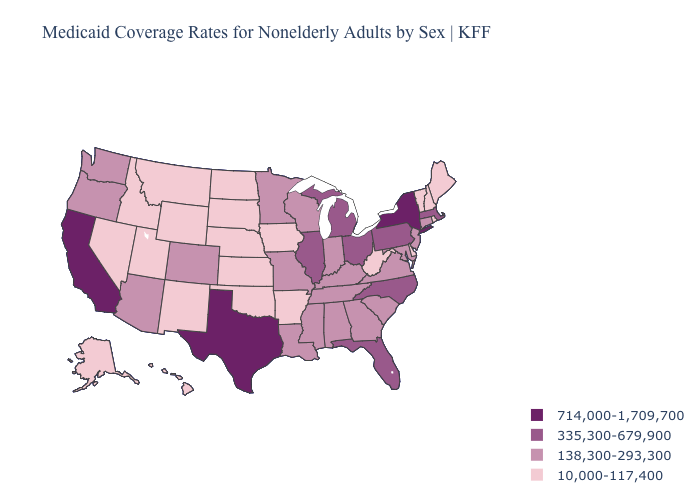Does Washington have a lower value than Ohio?
Keep it brief. Yes. Name the states that have a value in the range 10,000-117,400?
Concise answer only. Alaska, Arkansas, Delaware, Hawaii, Idaho, Iowa, Kansas, Maine, Montana, Nebraska, Nevada, New Hampshire, New Mexico, North Dakota, Oklahoma, Rhode Island, South Dakota, Utah, Vermont, West Virginia, Wyoming. Does Colorado have the highest value in the USA?
Concise answer only. No. Name the states that have a value in the range 10,000-117,400?
Be succinct. Alaska, Arkansas, Delaware, Hawaii, Idaho, Iowa, Kansas, Maine, Montana, Nebraska, Nevada, New Hampshire, New Mexico, North Dakota, Oklahoma, Rhode Island, South Dakota, Utah, Vermont, West Virginia, Wyoming. What is the lowest value in states that border Kansas?
Give a very brief answer. 10,000-117,400. Name the states that have a value in the range 714,000-1,709,700?
Quick response, please. California, New York, Texas. How many symbols are there in the legend?
Keep it brief. 4. Name the states that have a value in the range 10,000-117,400?
Be succinct. Alaska, Arkansas, Delaware, Hawaii, Idaho, Iowa, Kansas, Maine, Montana, Nebraska, Nevada, New Hampshire, New Mexico, North Dakota, Oklahoma, Rhode Island, South Dakota, Utah, Vermont, West Virginia, Wyoming. Name the states that have a value in the range 138,300-293,300?
Keep it brief. Alabama, Arizona, Colorado, Connecticut, Georgia, Indiana, Kentucky, Louisiana, Maryland, Minnesota, Mississippi, Missouri, New Jersey, Oregon, South Carolina, Tennessee, Virginia, Washington, Wisconsin. Which states have the lowest value in the West?
Concise answer only. Alaska, Hawaii, Idaho, Montana, Nevada, New Mexico, Utah, Wyoming. Among the states that border California , which have the highest value?
Quick response, please. Arizona, Oregon. What is the value of New York?
Quick response, please. 714,000-1,709,700. Is the legend a continuous bar?
Concise answer only. No. Among the states that border North Carolina , which have the highest value?
Answer briefly. Georgia, South Carolina, Tennessee, Virginia. What is the highest value in states that border California?
Answer briefly. 138,300-293,300. 